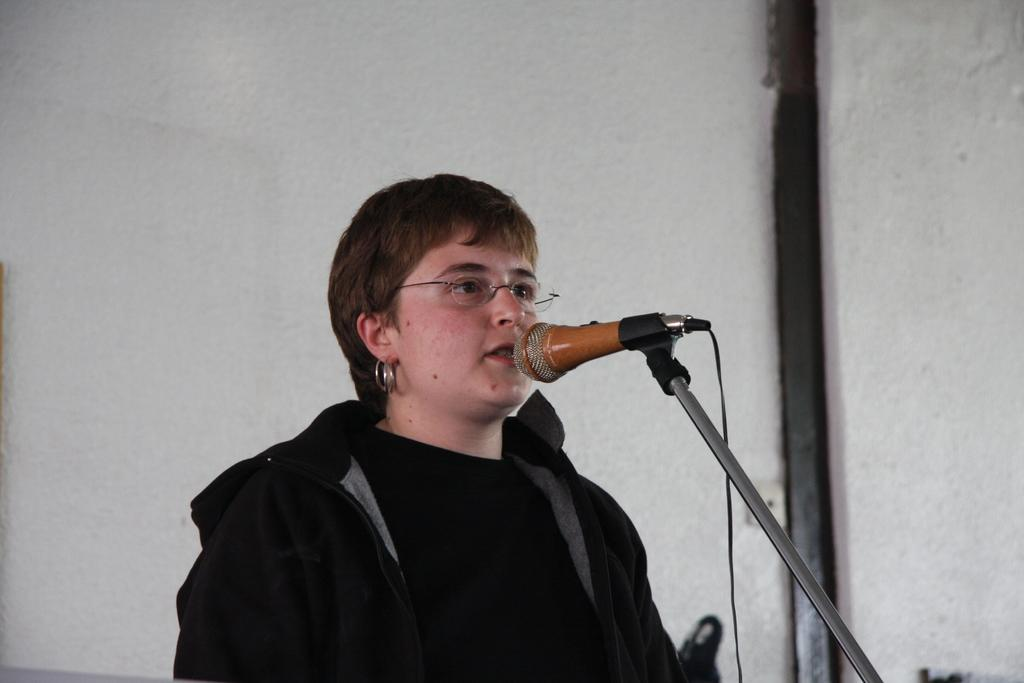Who or what is in the image? There is a person in the image. What is the person doing in the image? The person is in front of a mic. What can be seen behind the person? There is a wall in the background of the image. What type of agreement is being discussed by the group in the image? There is no group present in the image, and therefore no discussion or agreement can be observed. 